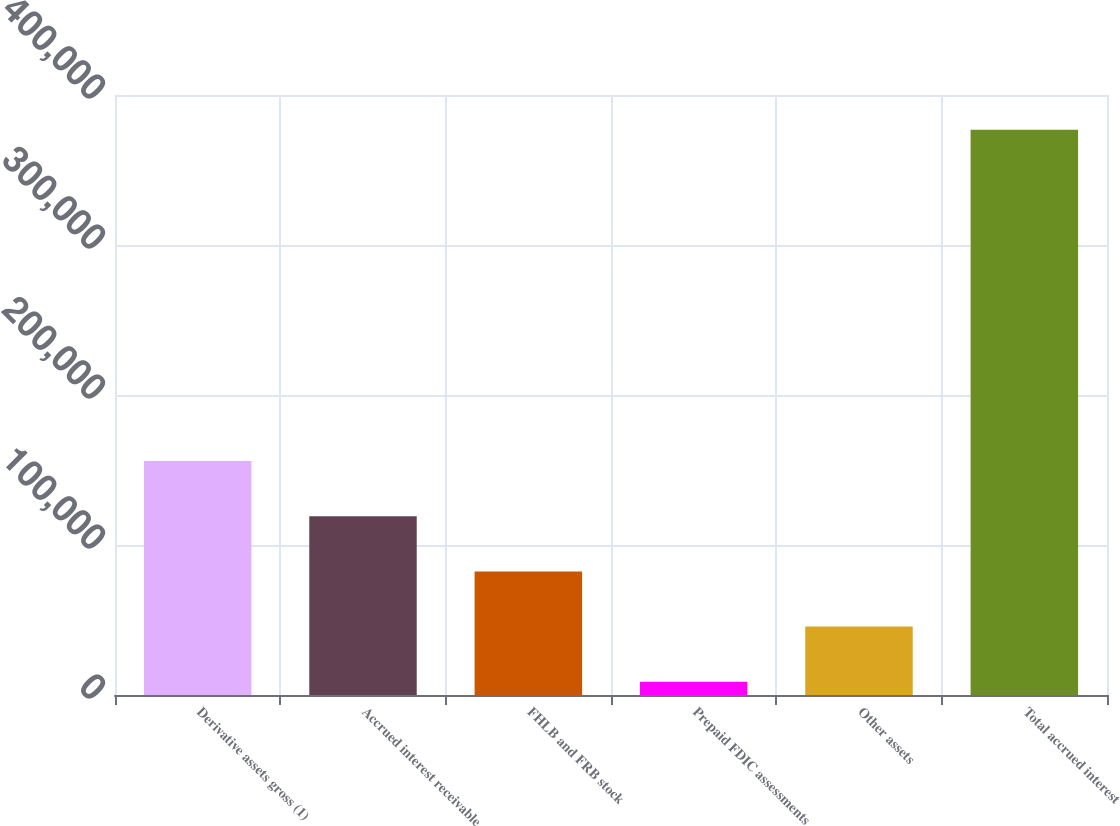Convert chart. <chart><loc_0><loc_0><loc_500><loc_500><bar_chart><fcel>Derivative assets gross (1)<fcel>Accrued interest receivable<fcel>FHLB and FRB stock<fcel>Prepaid FDIC assessments<fcel>Other assets<fcel>Total accrued interest<nl><fcel>156007<fcel>119199<fcel>82391.6<fcel>8776<fcel>45583.8<fcel>376854<nl></chart> 